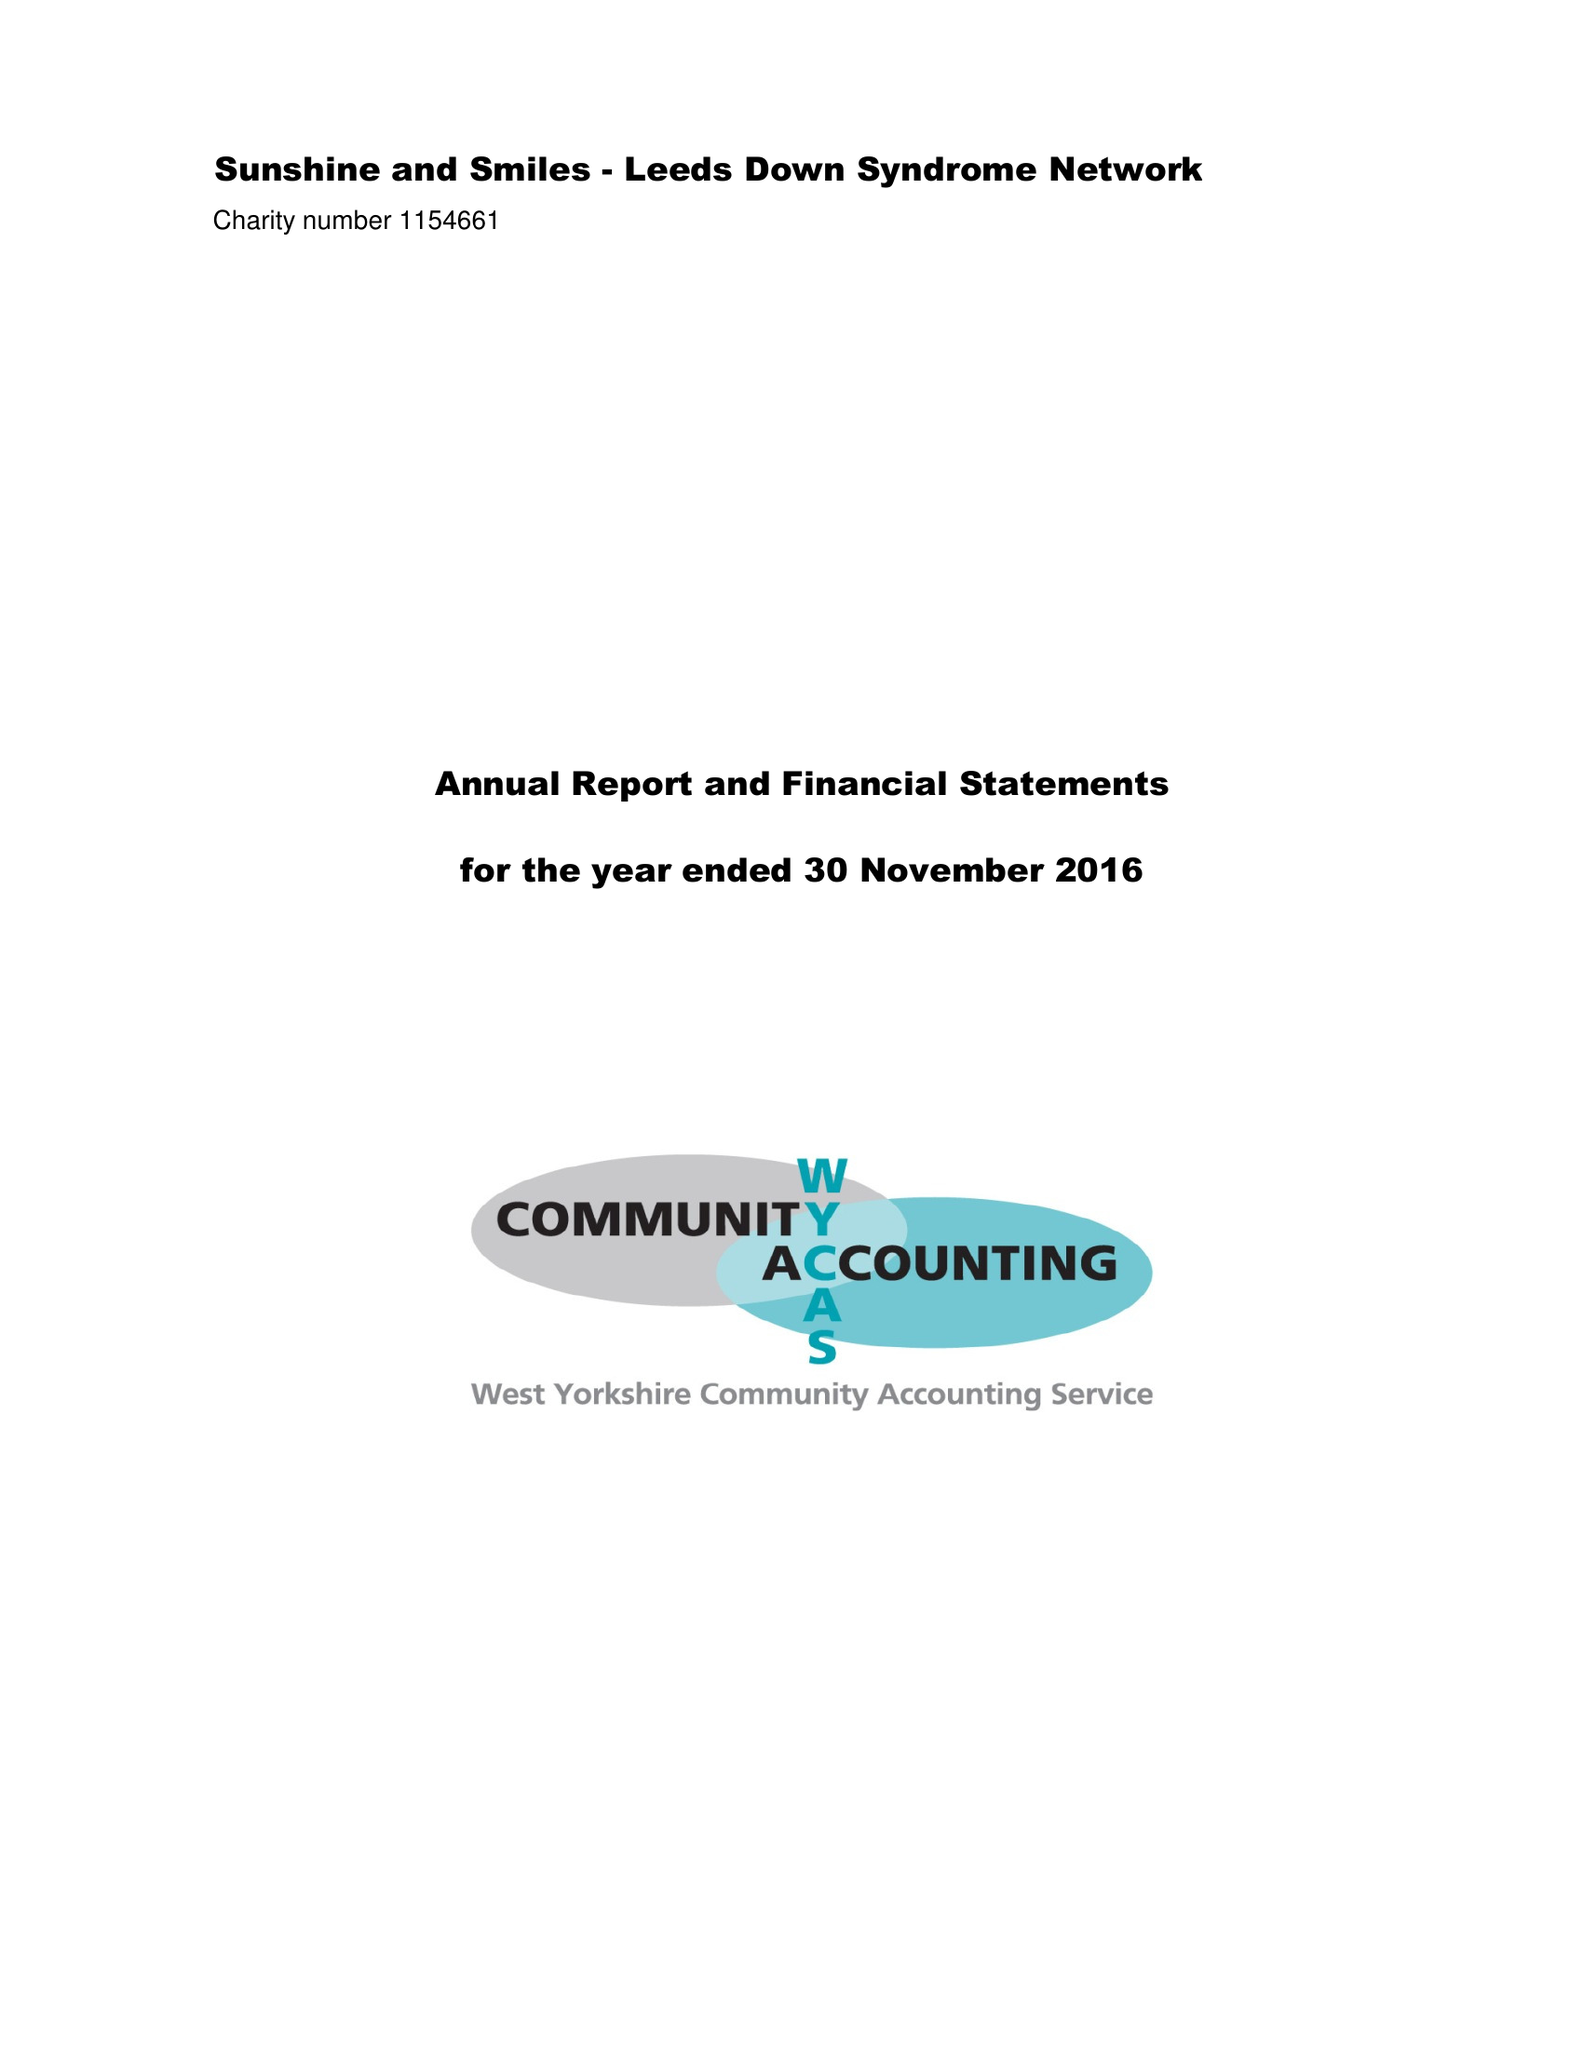What is the value for the address__postcode?
Answer the question using a single word or phrase. LS16 5LB 